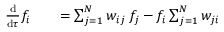Convert formula to latex. <formula><loc_0><loc_0><loc_500><loc_500>\begin{array} { r l r } { \frac { d } { d \tau } f _ { i } } & { = \sum _ { j = 1 } ^ { N } w _ { i j } \, f _ { j } - f _ { i } \sum _ { j = 1 } ^ { N } w _ { j i } } \end{array}</formula> 